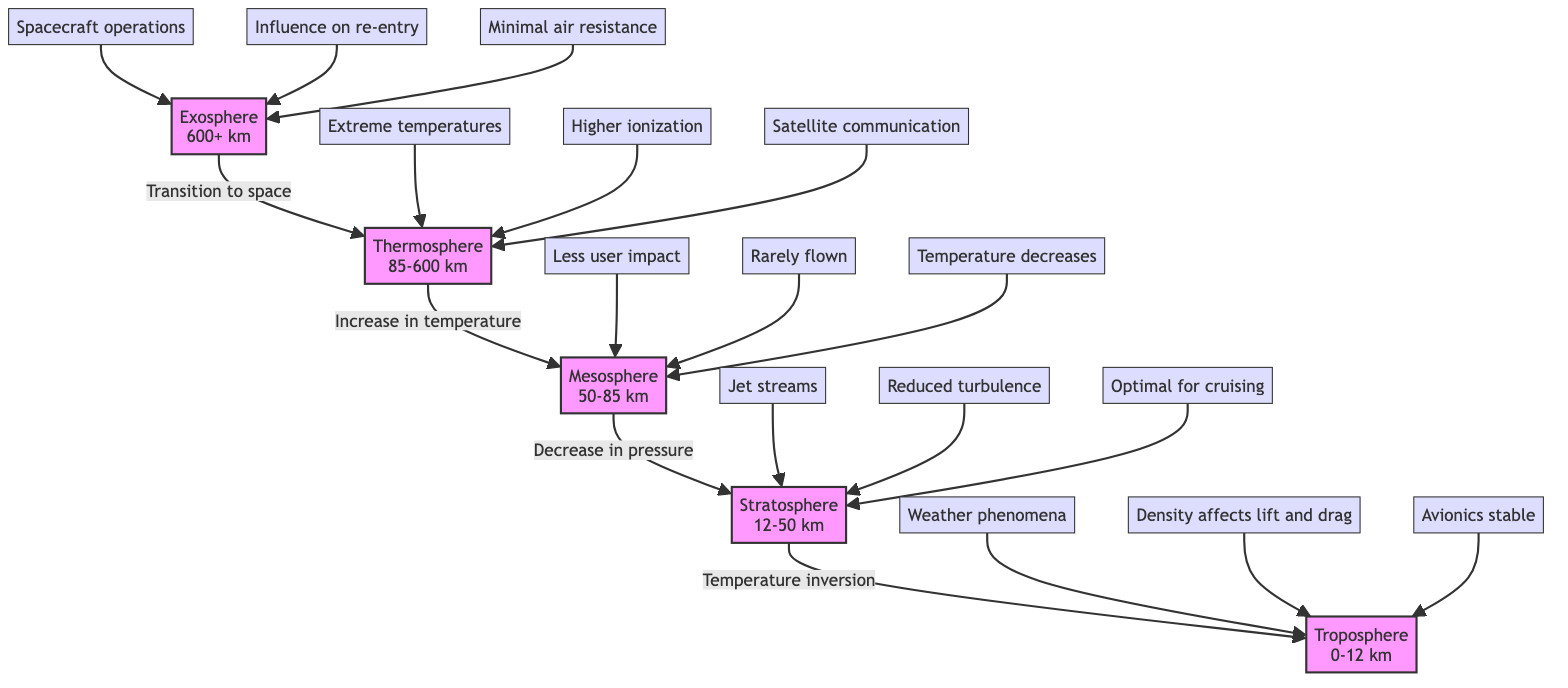What are the boundaries of the Troposphere? The Troposphere is bounded from 0 to 12 km according to the diagram.
Answer: 0-12 km What effect is associated with the Stratosphere? The diagram indicates that the Stratosphere is associated with "Temperature inversion."
Answer: Temperature inversion How many atmospheric layers are shown in the diagram? The diagram depicts five atmospheric layers: Exosphere, Thermosphere, Mesosphere, Stratosphere, and Troposphere.
Answer: 5 What is the effect mentioned for the Exosphere? One of the effects listed for the Exosphere is "Minimal air resistance."
Answer: Minimal air resistance What temperature trend is observed in the Mesosphere? The diagram denotes that the temperature decreases in the Mesosphere.
Answer: Decreases Which atmospheric layer is optimal for cruising? The Stratosphere is noted as being optimal for cruising in the diagram.
Answer: Stratosphere What phenomenon occurs within the Troposphere? The diagram states that "Weather phenomena" occur within the Troposphere.
Answer: Weather phenomena How does temperature change as you move from the Stratosphere to the Mesosphere? The transition from Stratosphere to Mesosphere shows a decrease in temperature according to the diagram.
Answer: Decrease What is a key effect of the Thermosphere? The diagram shows "Higher ionization" as a key effect of the Thermosphere.
Answer: Higher ionization 